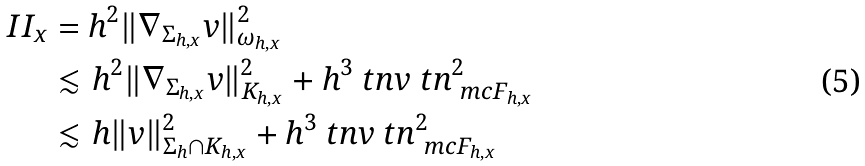Convert formula to latex. <formula><loc_0><loc_0><loc_500><loc_500>I I _ { x } & = h ^ { 2 } \| \nabla _ { \Sigma _ { h , x } } v \| ^ { 2 } _ { \omega _ { h , x } } \\ & \lesssim h ^ { 2 } \| \nabla _ { \Sigma _ { h , x } } v \| ^ { 2 } _ { K _ { h , x } } + h ^ { 3 } \ t n v \ t n ^ { 2 } _ { \ m c F _ { h , x } } \\ & \lesssim h \| v \| ^ { 2 } _ { \Sigma _ { h } \cap K _ { h , x } } + h ^ { 3 } \ t n v \ t n ^ { 2 } _ { \ m c F _ { h , x } }</formula> 